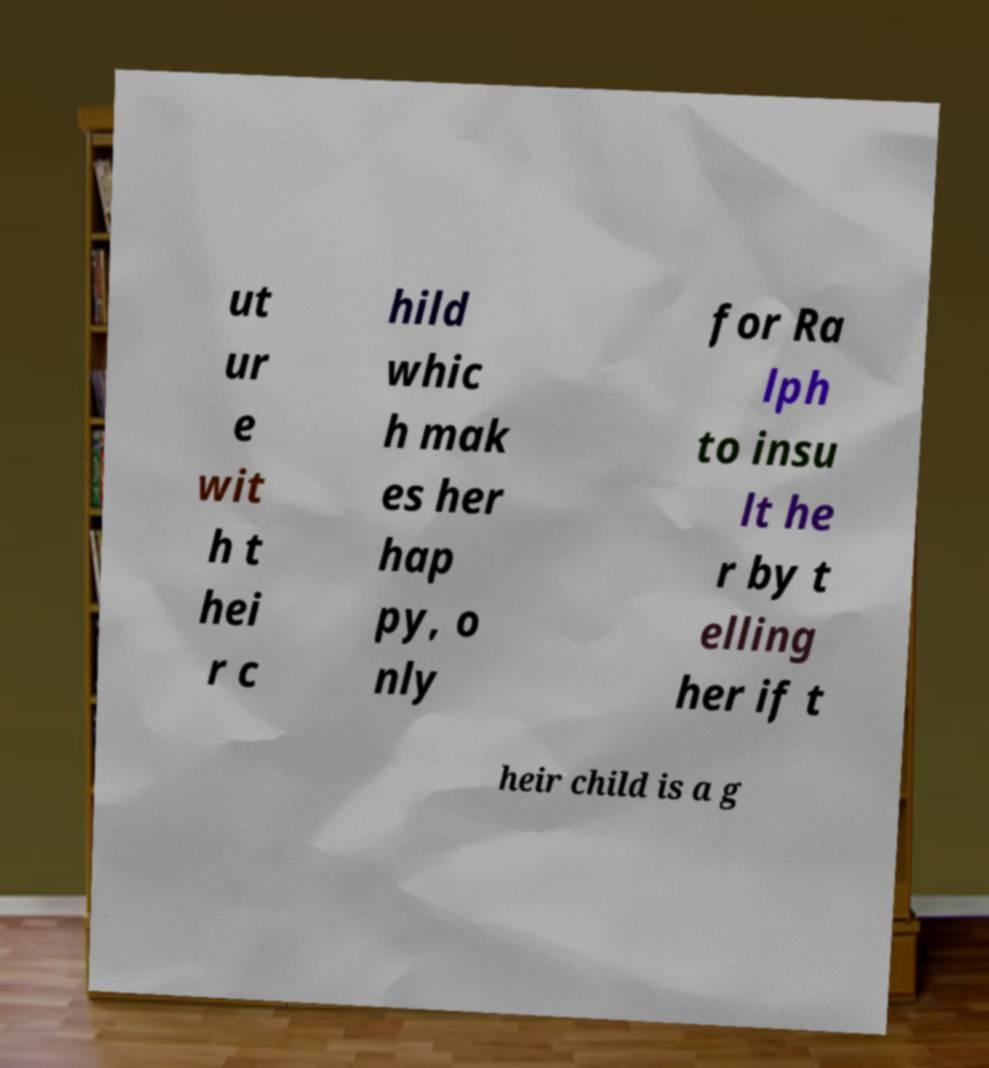For documentation purposes, I need the text within this image transcribed. Could you provide that? ut ur e wit h t hei r c hild whic h mak es her hap py, o nly for Ra lph to insu lt he r by t elling her if t heir child is a g 